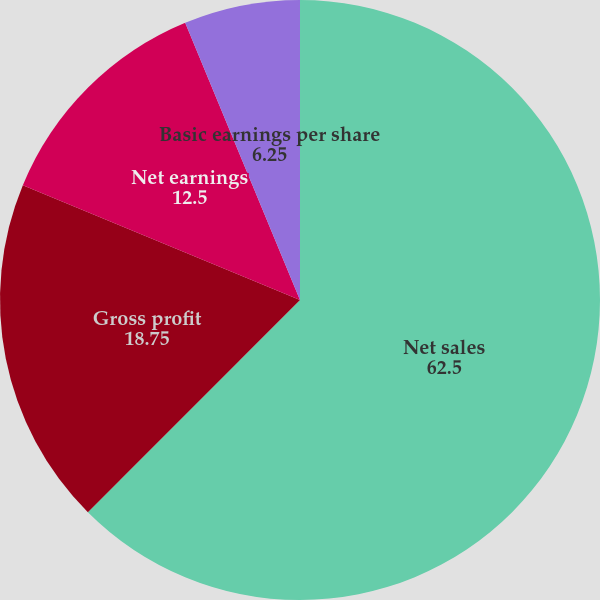<chart> <loc_0><loc_0><loc_500><loc_500><pie_chart><fcel>Net sales<fcel>Gross profit<fcel>Net earnings<fcel>Basic earnings per share<fcel>Diluted earnings per share<nl><fcel>62.5%<fcel>18.75%<fcel>12.5%<fcel>6.25%<fcel>0.0%<nl></chart> 